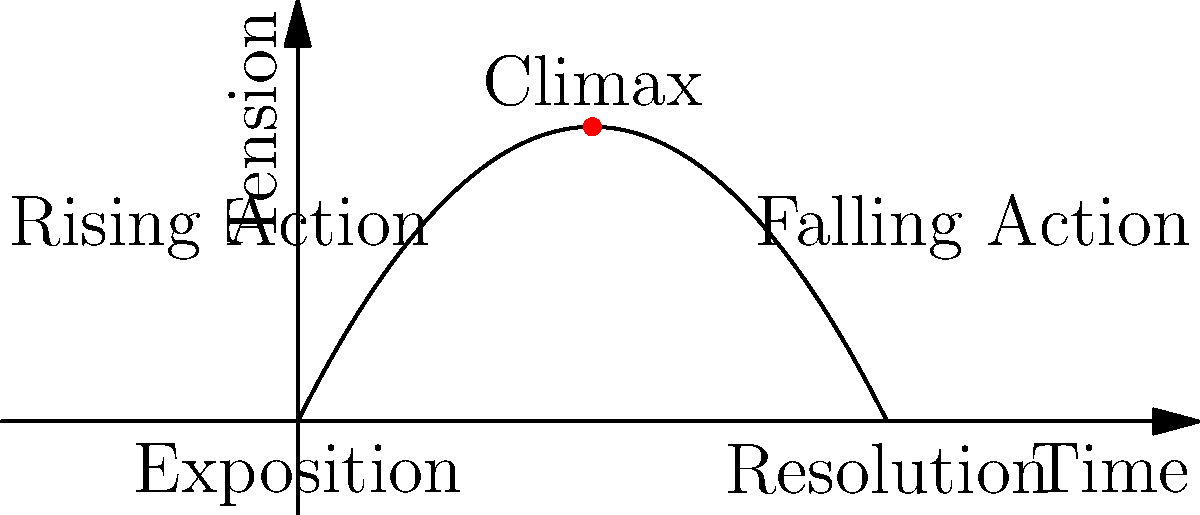In the three-act structure mountain chart shown, which element of storytelling does the highest point of the curve represent, and how does this relate to character development in your scripts? 1. Examine the mountain chart: The chart represents the three-act structure of a story, with time on the x-axis and tension on the y-axis.

2. Identify the curve's peak: The highest point of the curve is at the center of the graph, labeled "Climax."

3. Understand the climax: In storytelling, the climax is the moment of highest tension or conflict in the narrative. It's typically where the main character faces their greatest challenge.

4. Relate to character development: The climax is crucial for character development as it:
   a) Forces the protagonist to make critical decisions
   b) Tests the character's growth throughout the story
   c) Often leads to a significant change or realization in the character

5. Consider scriptwriting application: As a scriptwriter known for compelling character-driven narratives, you would likely use the climax to:
   a) Showcase the culmination of your character's journey
   b) Reveal the true nature of your character under extreme pressure
   c) Create a memorable, emotionally resonant moment that defines your character
Answer: Climax; pivotal moment for character growth and transformation 